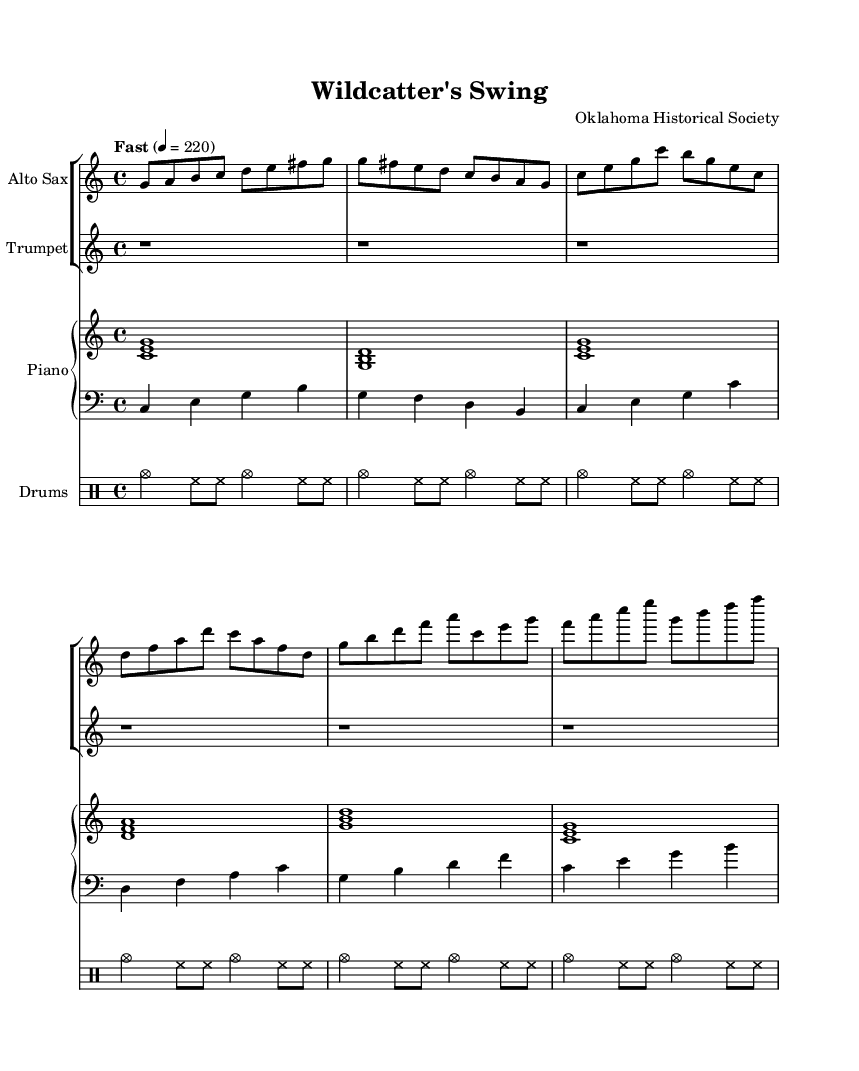What is the key signature of this music? The key signature is C major, which has no sharps or flats indicated at the beginning of the staff.
Answer: C major What is the time signature of this composition? The time signature is 4/4, meaning there are four beats in each measure, as indicated at the beginning of the score.
Answer: 4/4 What is the tempo marking for this piece? The tempo marking is indicated as "Fast" with a metronome marking of 220 beats per minute, telling the performer to play at a quick pace.
Answer: Fast How many measures are in the B section? The B section contains two measures, counted directly from the music notation where it starts and finishes in the provided score.
Answer: 2 Which instruments are featured in this arrangement? The arrangement includes an Alto Sax, Trumpet, Piano, Bass, and Drums, as seen in the staff group and instrument names at the beginning.
Answer: Alto Sax, Trumpet, Piano, Bass, Drums Which section has a shorter melody, A or B? The A section has a shorter melody, as it consists of four measures compared to the B section, which has two measures of more melodic content.
Answer: A 